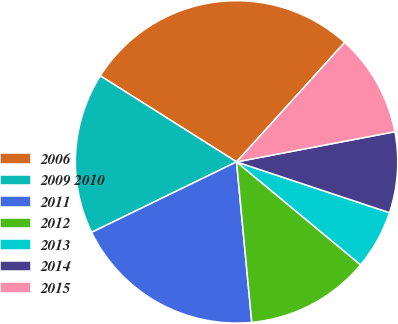Convert chart. <chart><loc_0><loc_0><loc_500><loc_500><pie_chart><fcel>2006<fcel>2009 2010<fcel>2011<fcel>2012<fcel>2013<fcel>2014<fcel>2015<nl><fcel>27.74%<fcel>16.17%<fcel>19.3%<fcel>12.47%<fcel>5.92%<fcel>8.1%<fcel>10.29%<nl></chart> 